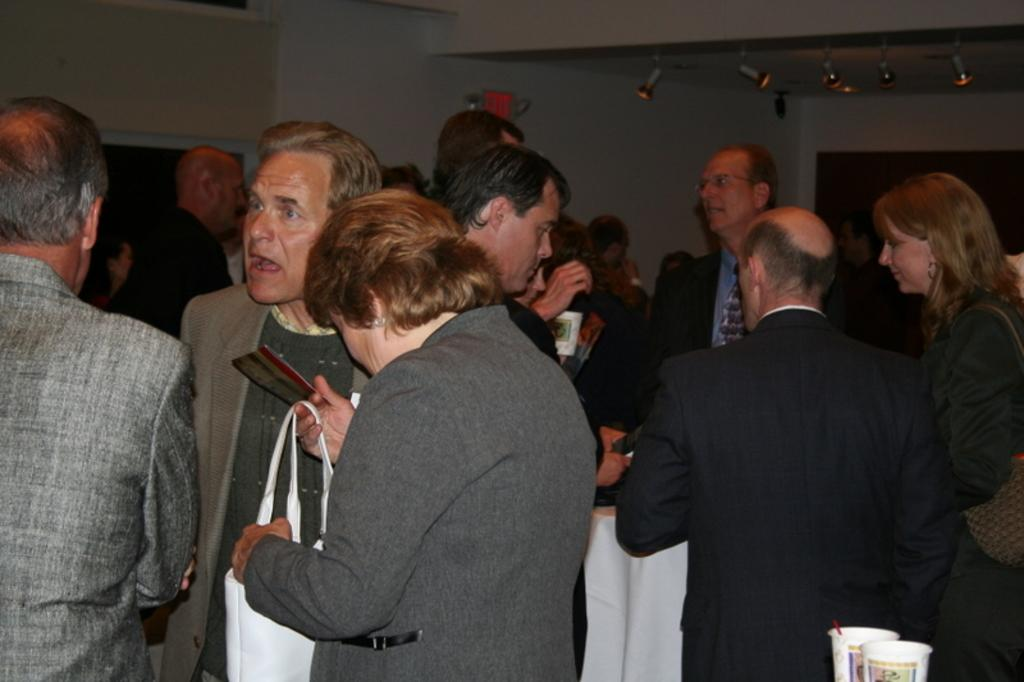How many people are in the image? There are people in the image, but the exact number is not specified. What is one person holding in the image? One person is holding a bag in the image. What can be seen in the background of the image? There is a wall and lights in the background of the image. Where are the glasses located in the image? The glasses are in the bottom right side of the image. How many ladybugs are resting on the wall in the image? There are no ladybugs present in the image, so it is not possible to determine how many might be resting on the wall. 